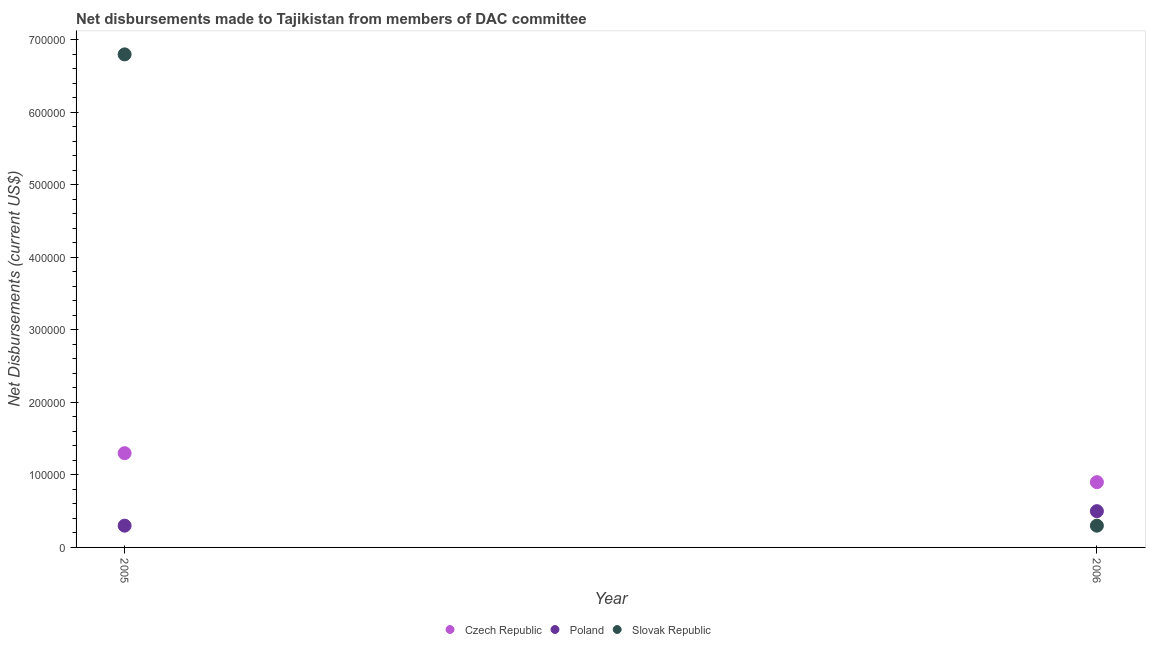How many different coloured dotlines are there?
Offer a terse response. 3. Is the number of dotlines equal to the number of legend labels?
Give a very brief answer. Yes. What is the net disbursements made by czech republic in 2006?
Provide a short and direct response. 9.00e+04. Across all years, what is the maximum net disbursements made by czech republic?
Offer a terse response. 1.30e+05. Across all years, what is the minimum net disbursements made by czech republic?
Provide a succinct answer. 9.00e+04. In which year was the net disbursements made by czech republic minimum?
Make the answer very short. 2006. What is the total net disbursements made by slovak republic in the graph?
Provide a succinct answer. 7.10e+05. What is the difference between the net disbursements made by slovak republic in 2005 and that in 2006?
Your response must be concise. 6.50e+05. What is the difference between the net disbursements made by poland in 2006 and the net disbursements made by czech republic in 2005?
Ensure brevity in your answer.  -8.00e+04. What is the average net disbursements made by slovak republic per year?
Your response must be concise. 3.55e+05. In the year 2006, what is the difference between the net disbursements made by slovak republic and net disbursements made by czech republic?
Provide a succinct answer. -6.00e+04. Is the net disbursements made by slovak republic in 2005 less than that in 2006?
Provide a succinct answer. No. Is it the case that in every year, the sum of the net disbursements made by czech republic and net disbursements made by poland is greater than the net disbursements made by slovak republic?
Your response must be concise. No. Does the net disbursements made by poland monotonically increase over the years?
Provide a succinct answer. Yes. Is the net disbursements made by slovak republic strictly greater than the net disbursements made by poland over the years?
Offer a terse response. No. Is the net disbursements made by slovak republic strictly less than the net disbursements made by czech republic over the years?
Your response must be concise. No. How many dotlines are there?
Offer a terse response. 3. How many years are there in the graph?
Offer a terse response. 2. What is the difference between two consecutive major ticks on the Y-axis?
Provide a short and direct response. 1.00e+05. Where does the legend appear in the graph?
Provide a succinct answer. Bottom center. How are the legend labels stacked?
Keep it short and to the point. Horizontal. What is the title of the graph?
Your response must be concise. Net disbursements made to Tajikistan from members of DAC committee. What is the label or title of the X-axis?
Your answer should be compact. Year. What is the label or title of the Y-axis?
Make the answer very short. Net Disbursements (current US$). What is the Net Disbursements (current US$) of Slovak Republic in 2005?
Provide a short and direct response. 6.80e+05. What is the Net Disbursements (current US$) of Czech Republic in 2006?
Your response must be concise. 9.00e+04. What is the Net Disbursements (current US$) of Slovak Republic in 2006?
Offer a terse response. 3.00e+04. Across all years, what is the maximum Net Disbursements (current US$) of Poland?
Your answer should be compact. 5.00e+04. Across all years, what is the maximum Net Disbursements (current US$) of Slovak Republic?
Your answer should be very brief. 6.80e+05. Across all years, what is the minimum Net Disbursements (current US$) of Czech Republic?
Your answer should be compact. 9.00e+04. What is the total Net Disbursements (current US$) of Slovak Republic in the graph?
Your answer should be compact. 7.10e+05. What is the difference between the Net Disbursements (current US$) in Poland in 2005 and that in 2006?
Your answer should be very brief. -2.00e+04. What is the difference between the Net Disbursements (current US$) of Slovak Republic in 2005 and that in 2006?
Make the answer very short. 6.50e+05. What is the difference between the Net Disbursements (current US$) in Czech Republic in 2005 and the Net Disbursements (current US$) in Poland in 2006?
Ensure brevity in your answer.  8.00e+04. What is the difference between the Net Disbursements (current US$) in Czech Republic in 2005 and the Net Disbursements (current US$) in Slovak Republic in 2006?
Make the answer very short. 1.00e+05. What is the average Net Disbursements (current US$) in Czech Republic per year?
Give a very brief answer. 1.10e+05. What is the average Net Disbursements (current US$) of Slovak Republic per year?
Make the answer very short. 3.55e+05. In the year 2005, what is the difference between the Net Disbursements (current US$) of Czech Republic and Net Disbursements (current US$) of Poland?
Ensure brevity in your answer.  1.00e+05. In the year 2005, what is the difference between the Net Disbursements (current US$) of Czech Republic and Net Disbursements (current US$) of Slovak Republic?
Offer a very short reply. -5.50e+05. In the year 2005, what is the difference between the Net Disbursements (current US$) of Poland and Net Disbursements (current US$) of Slovak Republic?
Offer a terse response. -6.50e+05. What is the ratio of the Net Disbursements (current US$) in Czech Republic in 2005 to that in 2006?
Provide a succinct answer. 1.44. What is the ratio of the Net Disbursements (current US$) in Poland in 2005 to that in 2006?
Make the answer very short. 0.6. What is the ratio of the Net Disbursements (current US$) of Slovak Republic in 2005 to that in 2006?
Provide a succinct answer. 22.67. What is the difference between the highest and the second highest Net Disbursements (current US$) in Poland?
Provide a short and direct response. 2.00e+04. What is the difference between the highest and the second highest Net Disbursements (current US$) of Slovak Republic?
Ensure brevity in your answer.  6.50e+05. What is the difference between the highest and the lowest Net Disbursements (current US$) in Poland?
Ensure brevity in your answer.  2.00e+04. What is the difference between the highest and the lowest Net Disbursements (current US$) of Slovak Republic?
Give a very brief answer. 6.50e+05. 